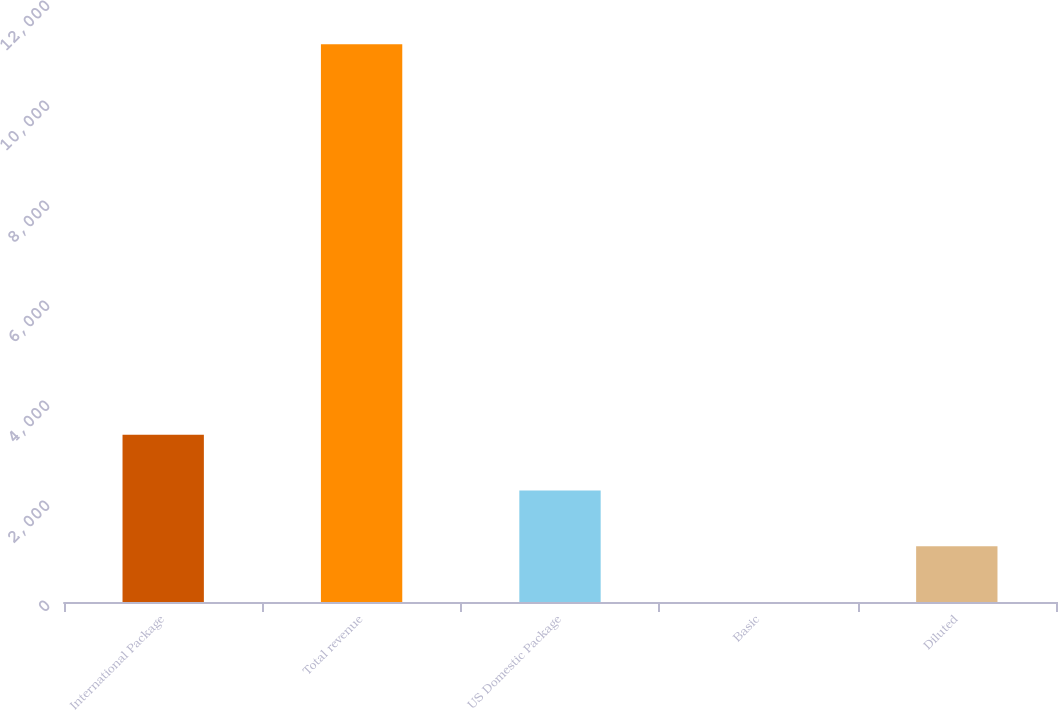<chart> <loc_0><loc_0><loc_500><loc_500><bar_chart><fcel>International Package<fcel>Total revenue<fcel>US Domestic Package<fcel>Basic<fcel>Diluted<nl><fcel>3346.3<fcel>11153<fcel>2231.05<fcel>0.55<fcel>1115.8<nl></chart> 